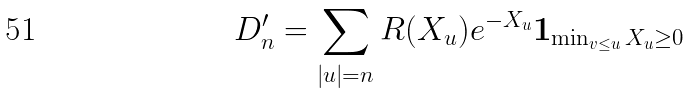Convert formula to latex. <formula><loc_0><loc_0><loc_500><loc_500>D _ { n } ^ { \prime } = \sum _ { | u | = n } R ( X _ { u } ) e ^ { - X _ { u } } \boldsymbol 1 _ { \min _ { v \leq u } X _ { u } \geq 0 }</formula> 